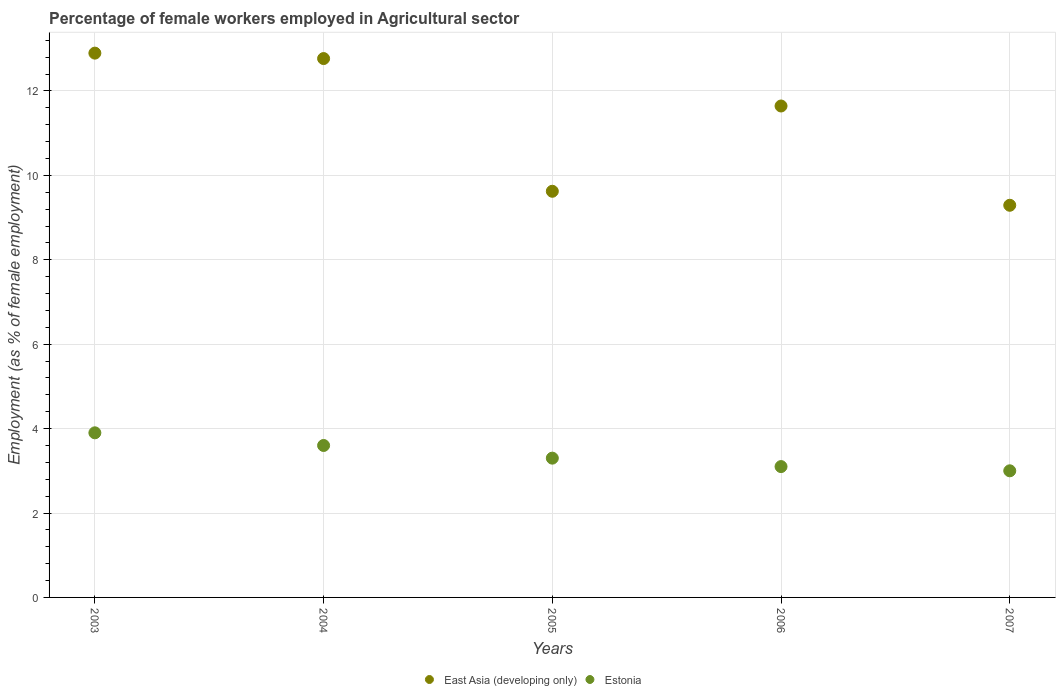Is the number of dotlines equal to the number of legend labels?
Keep it short and to the point. Yes. What is the percentage of females employed in Agricultural sector in East Asia (developing only) in 2005?
Your response must be concise. 9.62. Across all years, what is the maximum percentage of females employed in Agricultural sector in East Asia (developing only)?
Make the answer very short. 12.9. Across all years, what is the minimum percentage of females employed in Agricultural sector in East Asia (developing only)?
Provide a short and direct response. 9.29. What is the total percentage of females employed in Agricultural sector in East Asia (developing only) in the graph?
Make the answer very short. 56.22. What is the difference between the percentage of females employed in Agricultural sector in Estonia in 2004 and that in 2005?
Offer a terse response. 0.3. What is the difference between the percentage of females employed in Agricultural sector in East Asia (developing only) in 2004 and the percentage of females employed in Agricultural sector in Estonia in 2005?
Offer a very short reply. 9.47. What is the average percentage of females employed in Agricultural sector in East Asia (developing only) per year?
Provide a short and direct response. 11.24. In the year 2003, what is the difference between the percentage of females employed in Agricultural sector in Estonia and percentage of females employed in Agricultural sector in East Asia (developing only)?
Your answer should be compact. -9. What is the ratio of the percentage of females employed in Agricultural sector in Estonia in 2003 to that in 2005?
Make the answer very short. 1.18. What is the difference between the highest and the second highest percentage of females employed in Agricultural sector in Estonia?
Your response must be concise. 0.3. What is the difference between the highest and the lowest percentage of females employed in Agricultural sector in East Asia (developing only)?
Offer a very short reply. 3.6. Is the sum of the percentage of females employed in Agricultural sector in Estonia in 2003 and 2007 greater than the maximum percentage of females employed in Agricultural sector in East Asia (developing only) across all years?
Make the answer very short. No. Is the percentage of females employed in Agricultural sector in East Asia (developing only) strictly less than the percentage of females employed in Agricultural sector in Estonia over the years?
Your answer should be compact. No. How many dotlines are there?
Keep it short and to the point. 2. How many years are there in the graph?
Your response must be concise. 5. Where does the legend appear in the graph?
Provide a succinct answer. Bottom center. How many legend labels are there?
Your response must be concise. 2. How are the legend labels stacked?
Offer a terse response. Horizontal. What is the title of the graph?
Keep it short and to the point. Percentage of female workers employed in Agricultural sector. What is the label or title of the X-axis?
Keep it short and to the point. Years. What is the label or title of the Y-axis?
Offer a terse response. Employment (as % of female employment). What is the Employment (as % of female employment) of East Asia (developing only) in 2003?
Your answer should be compact. 12.9. What is the Employment (as % of female employment) in Estonia in 2003?
Give a very brief answer. 3.9. What is the Employment (as % of female employment) in East Asia (developing only) in 2004?
Provide a short and direct response. 12.77. What is the Employment (as % of female employment) in Estonia in 2004?
Your answer should be very brief. 3.6. What is the Employment (as % of female employment) in East Asia (developing only) in 2005?
Provide a short and direct response. 9.62. What is the Employment (as % of female employment) in Estonia in 2005?
Your answer should be compact. 3.3. What is the Employment (as % of female employment) of East Asia (developing only) in 2006?
Provide a succinct answer. 11.64. What is the Employment (as % of female employment) of Estonia in 2006?
Provide a short and direct response. 3.1. What is the Employment (as % of female employment) of East Asia (developing only) in 2007?
Your response must be concise. 9.29. What is the Employment (as % of female employment) of Estonia in 2007?
Offer a very short reply. 3. Across all years, what is the maximum Employment (as % of female employment) in East Asia (developing only)?
Make the answer very short. 12.9. Across all years, what is the maximum Employment (as % of female employment) of Estonia?
Offer a terse response. 3.9. Across all years, what is the minimum Employment (as % of female employment) of East Asia (developing only)?
Offer a very short reply. 9.29. Across all years, what is the minimum Employment (as % of female employment) in Estonia?
Your answer should be very brief. 3. What is the total Employment (as % of female employment) in East Asia (developing only) in the graph?
Provide a short and direct response. 56.22. What is the difference between the Employment (as % of female employment) of East Asia (developing only) in 2003 and that in 2004?
Provide a short and direct response. 0.13. What is the difference between the Employment (as % of female employment) in East Asia (developing only) in 2003 and that in 2005?
Give a very brief answer. 3.27. What is the difference between the Employment (as % of female employment) of East Asia (developing only) in 2003 and that in 2006?
Make the answer very short. 1.25. What is the difference between the Employment (as % of female employment) of East Asia (developing only) in 2003 and that in 2007?
Your answer should be very brief. 3.6. What is the difference between the Employment (as % of female employment) in Estonia in 2003 and that in 2007?
Keep it short and to the point. 0.9. What is the difference between the Employment (as % of female employment) of East Asia (developing only) in 2004 and that in 2005?
Your response must be concise. 3.14. What is the difference between the Employment (as % of female employment) in East Asia (developing only) in 2004 and that in 2006?
Provide a succinct answer. 1.12. What is the difference between the Employment (as % of female employment) of Estonia in 2004 and that in 2006?
Your answer should be compact. 0.5. What is the difference between the Employment (as % of female employment) of East Asia (developing only) in 2004 and that in 2007?
Give a very brief answer. 3.48. What is the difference between the Employment (as % of female employment) of Estonia in 2004 and that in 2007?
Provide a short and direct response. 0.6. What is the difference between the Employment (as % of female employment) in East Asia (developing only) in 2005 and that in 2006?
Offer a terse response. -2.02. What is the difference between the Employment (as % of female employment) in East Asia (developing only) in 2005 and that in 2007?
Ensure brevity in your answer.  0.33. What is the difference between the Employment (as % of female employment) of Estonia in 2005 and that in 2007?
Provide a short and direct response. 0.3. What is the difference between the Employment (as % of female employment) of East Asia (developing only) in 2006 and that in 2007?
Your response must be concise. 2.35. What is the difference between the Employment (as % of female employment) in Estonia in 2006 and that in 2007?
Offer a terse response. 0.1. What is the difference between the Employment (as % of female employment) of East Asia (developing only) in 2003 and the Employment (as % of female employment) of Estonia in 2004?
Offer a terse response. 9.3. What is the difference between the Employment (as % of female employment) of East Asia (developing only) in 2003 and the Employment (as % of female employment) of Estonia in 2005?
Provide a succinct answer. 9.6. What is the difference between the Employment (as % of female employment) in East Asia (developing only) in 2003 and the Employment (as % of female employment) in Estonia in 2006?
Ensure brevity in your answer.  9.8. What is the difference between the Employment (as % of female employment) in East Asia (developing only) in 2003 and the Employment (as % of female employment) in Estonia in 2007?
Your answer should be compact. 9.9. What is the difference between the Employment (as % of female employment) in East Asia (developing only) in 2004 and the Employment (as % of female employment) in Estonia in 2005?
Provide a short and direct response. 9.47. What is the difference between the Employment (as % of female employment) in East Asia (developing only) in 2004 and the Employment (as % of female employment) in Estonia in 2006?
Your answer should be compact. 9.67. What is the difference between the Employment (as % of female employment) in East Asia (developing only) in 2004 and the Employment (as % of female employment) in Estonia in 2007?
Make the answer very short. 9.77. What is the difference between the Employment (as % of female employment) of East Asia (developing only) in 2005 and the Employment (as % of female employment) of Estonia in 2006?
Ensure brevity in your answer.  6.52. What is the difference between the Employment (as % of female employment) in East Asia (developing only) in 2005 and the Employment (as % of female employment) in Estonia in 2007?
Your response must be concise. 6.62. What is the difference between the Employment (as % of female employment) in East Asia (developing only) in 2006 and the Employment (as % of female employment) in Estonia in 2007?
Your answer should be compact. 8.64. What is the average Employment (as % of female employment) of East Asia (developing only) per year?
Keep it short and to the point. 11.24. What is the average Employment (as % of female employment) in Estonia per year?
Provide a short and direct response. 3.38. In the year 2003, what is the difference between the Employment (as % of female employment) in East Asia (developing only) and Employment (as % of female employment) in Estonia?
Provide a succinct answer. 9. In the year 2004, what is the difference between the Employment (as % of female employment) of East Asia (developing only) and Employment (as % of female employment) of Estonia?
Your answer should be compact. 9.17. In the year 2005, what is the difference between the Employment (as % of female employment) of East Asia (developing only) and Employment (as % of female employment) of Estonia?
Ensure brevity in your answer.  6.32. In the year 2006, what is the difference between the Employment (as % of female employment) of East Asia (developing only) and Employment (as % of female employment) of Estonia?
Keep it short and to the point. 8.54. In the year 2007, what is the difference between the Employment (as % of female employment) of East Asia (developing only) and Employment (as % of female employment) of Estonia?
Offer a terse response. 6.29. What is the ratio of the Employment (as % of female employment) in Estonia in 2003 to that in 2004?
Give a very brief answer. 1.08. What is the ratio of the Employment (as % of female employment) of East Asia (developing only) in 2003 to that in 2005?
Ensure brevity in your answer.  1.34. What is the ratio of the Employment (as % of female employment) in Estonia in 2003 to that in 2005?
Make the answer very short. 1.18. What is the ratio of the Employment (as % of female employment) of East Asia (developing only) in 2003 to that in 2006?
Offer a very short reply. 1.11. What is the ratio of the Employment (as % of female employment) of Estonia in 2003 to that in 2006?
Offer a terse response. 1.26. What is the ratio of the Employment (as % of female employment) of East Asia (developing only) in 2003 to that in 2007?
Give a very brief answer. 1.39. What is the ratio of the Employment (as % of female employment) of East Asia (developing only) in 2004 to that in 2005?
Ensure brevity in your answer.  1.33. What is the ratio of the Employment (as % of female employment) of East Asia (developing only) in 2004 to that in 2006?
Ensure brevity in your answer.  1.1. What is the ratio of the Employment (as % of female employment) in Estonia in 2004 to that in 2006?
Give a very brief answer. 1.16. What is the ratio of the Employment (as % of female employment) of East Asia (developing only) in 2004 to that in 2007?
Ensure brevity in your answer.  1.37. What is the ratio of the Employment (as % of female employment) in Estonia in 2004 to that in 2007?
Your response must be concise. 1.2. What is the ratio of the Employment (as % of female employment) of East Asia (developing only) in 2005 to that in 2006?
Ensure brevity in your answer.  0.83. What is the ratio of the Employment (as % of female employment) in Estonia in 2005 to that in 2006?
Make the answer very short. 1.06. What is the ratio of the Employment (as % of female employment) of East Asia (developing only) in 2005 to that in 2007?
Give a very brief answer. 1.04. What is the ratio of the Employment (as % of female employment) of East Asia (developing only) in 2006 to that in 2007?
Provide a short and direct response. 1.25. What is the ratio of the Employment (as % of female employment) of Estonia in 2006 to that in 2007?
Your response must be concise. 1.03. What is the difference between the highest and the second highest Employment (as % of female employment) of East Asia (developing only)?
Give a very brief answer. 0.13. What is the difference between the highest and the second highest Employment (as % of female employment) of Estonia?
Your answer should be compact. 0.3. What is the difference between the highest and the lowest Employment (as % of female employment) of East Asia (developing only)?
Make the answer very short. 3.6. What is the difference between the highest and the lowest Employment (as % of female employment) in Estonia?
Provide a short and direct response. 0.9. 